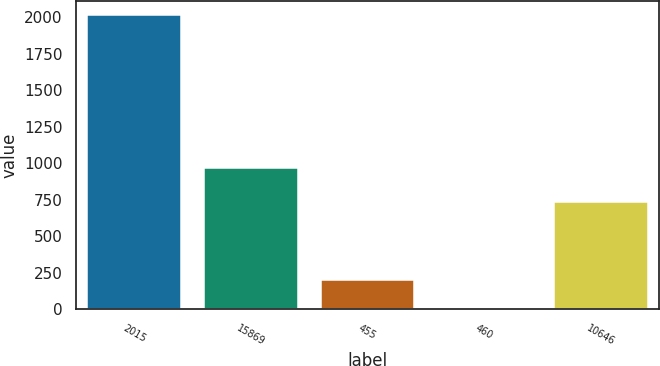Convert chart to OTSL. <chart><loc_0><loc_0><loc_500><loc_500><bar_chart><fcel>2015<fcel>15869<fcel>455<fcel>460<fcel>10646<nl><fcel>2011<fcel>967.6<fcel>203.31<fcel>2.46<fcel>735.6<nl></chart> 